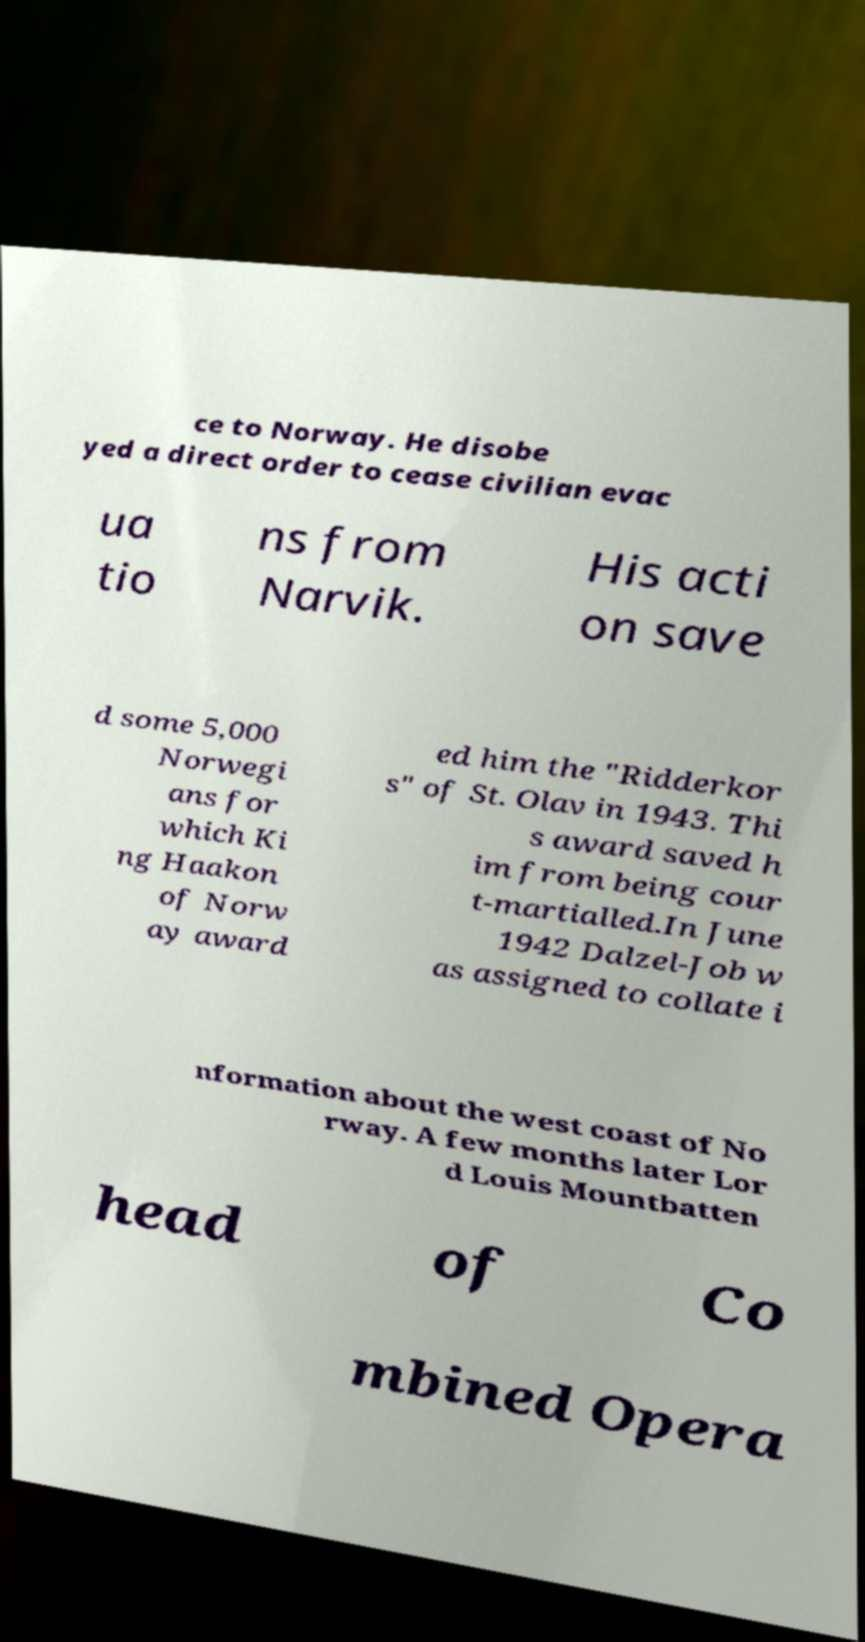For documentation purposes, I need the text within this image transcribed. Could you provide that? ce to Norway. He disobe yed a direct order to cease civilian evac ua tio ns from Narvik. His acti on save d some 5,000 Norwegi ans for which Ki ng Haakon of Norw ay award ed him the "Ridderkor s" of St. Olav in 1943. Thi s award saved h im from being cour t-martialled.In June 1942 Dalzel-Job w as assigned to collate i nformation about the west coast of No rway. A few months later Lor d Louis Mountbatten head of Co mbined Opera 